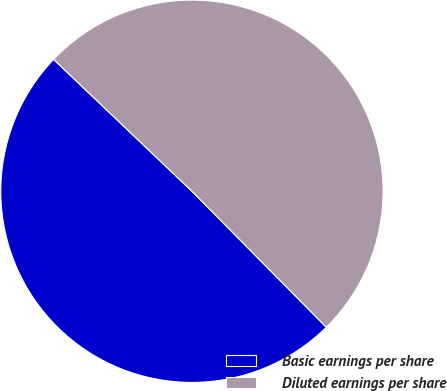<chart> <loc_0><loc_0><loc_500><loc_500><pie_chart><fcel>Basic earnings per share<fcel>Diluted earnings per share<nl><fcel>49.53%<fcel>50.47%<nl></chart> 